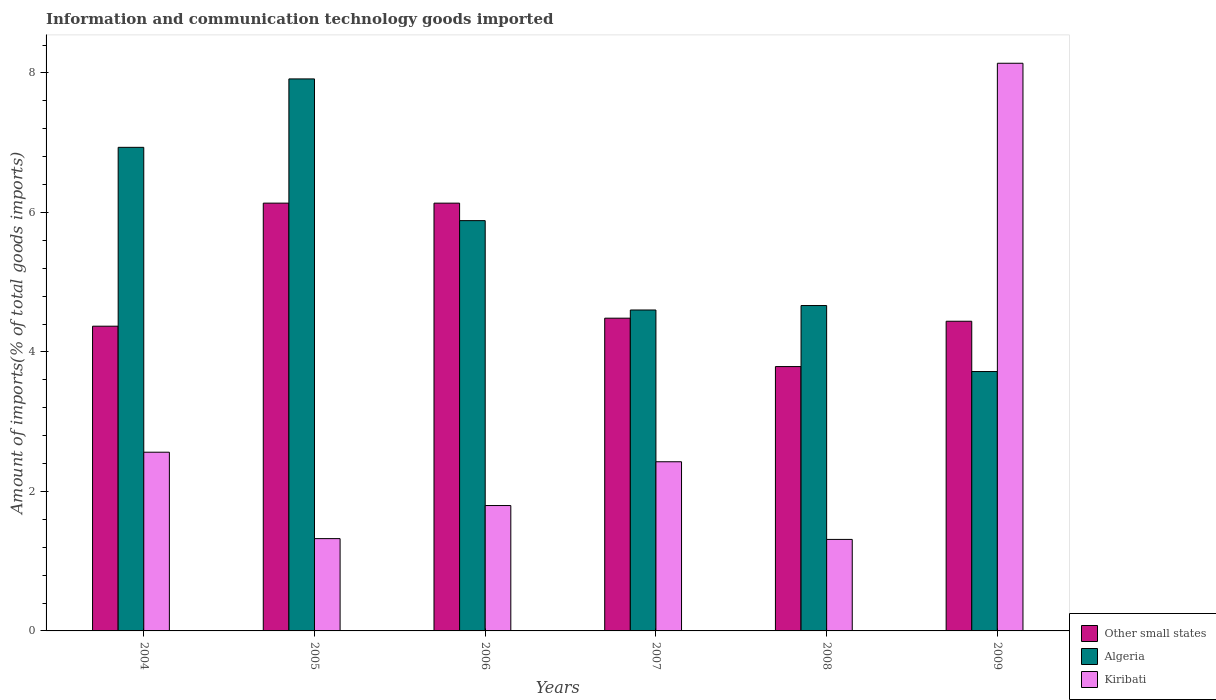How many different coloured bars are there?
Offer a very short reply. 3. How many groups of bars are there?
Offer a very short reply. 6. Are the number of bars on each tick of the X-axis equal?
Ensure brevity in your answer.  Yes. How many bars are there on the 3rd tick from the right?
Offer a very short reply. 3. What is the label of the 3rd group of bars from the left?
Give a very brief answer. 2006. What is the amount of goods imported in Kiribati in 2008?
Ensure brevity in your answer.  1.31. Across all years, what is the maximum amount of goods imported in Other small states?
Your answer should be very brief. 6.13. Across all years, what is the minimum amount of goods imported in Algeria?
Offer a terse response. 3.72. In which year was the amount of goods imported in Other small states minimum?
Provide a short and direct response. 2008. What is the total amount of goods imported in Kiribati in the graph?
Provide a succinct answer. 17.56. What is the difference between the amount of goods imported in Other small states in 2004 and that in 2007?
Your response must be concise. -0.11. What is the difference between the amount of goods imported in Algeria in 2005 and the amount of goods imported in Other small states in 2004?
Offer a terse response. 3.55. What is the average amount of goods imported in Kiribati per year?
Ensure brevity in your answer.  2.93. In the year 2005, what is the difference between the amount of goods imported in Algeria and amount of goods imported in Kiribati?
Offer a very short reply. 6.59. What is the ratio of the amount of goods imported in Kiribati in 2005 to that in 2007?
Make the answer very short. 0.55. Is the difference between the amount of goods imported in Algeria in 2005 and 2006 greater than the difference between the amount of goods imported in Kiribati in 2005 and 2006?
Your answer should be very brief. Yes. What is the difference between the highest and the second highest amount of goods imported in Kiribati?
Provide a short and direct response. 5.58. What is the difference between the highest and the lowest amount of goods imported in Kiribati?
Ensure brevity in your answer.  6.83. What does the 1st bar from the left in 2007 represents?
Ensure brevity in your answer.  Other small states. What does the 1st bar from the right in 2004 represents?
Offer a terse response. Kiribati. What is the difference between two consecutive major ticks on the Y-axis?
Give a very brief answer. 2. Are the values on the major ticks of Y-axis written in scientific E-notation?
Provide a succinct answer. No. How are the legend labels stacked?
Your response must be concise. Vertical. What is the title of the graph?
Provide a short and direct response. Information and communication technology goods imported. Does "Ecuador" appear as one of the legend labels in the graph?
Provide a succinct answer. No. What is the label or title of the Y-axis?
Your answer should be very brief. Amount of imports(% of total goods imports). What is the Amount of imports(% of total goods imports) in Other small states in 2004?
Provide a succinct answer. 4.37. What is the Amount of imports(% of total goods imports) of Algeria in 2004?
Provide a succinct answer. 6.93. What is the Amount of imports(% of total goods imports) of Kiribati in 2004?
Make the answer very short. 2.56. What is the Amount of imports(% of total goods imports) in Other small states in 2005?
Offer a terse response. 6.13. What is the Amount of imports(% of total goods imports) in Algeria in 2005?
Offer a terse response. 7.92. What is the Amount of imports(% of total goods imports) in Kiribati in 2005?
Your response must be concise. 1.32. What is the Amount of imports(% of total goods imports) in Other small states in 2006?
Ensure brevity in your answer.  6.13. What is the Amount of imports(% of total goods imports) of Algeria in 2006?
Provide a succinct answer. 5.88. What is the Amount of imports(% of total goods imports) in Kiribati in 2006?
Give a very brief answer. 1.8. What is the Amount of imports(% of total goods imports) of Other small states in 2007?
Keep it short and to the point. 4.48. What is the Amount of imports(% of total goods imports) of Algeria in 2007?
Your response must be concise. 4.6. What is the Amount of imports(% of total goods imports) in Kiribati in 2007?
Your answer should be compact. 2.43. What is the Amount of imports(% of total goods imports) of Other small states in 2008?
Your response must be concise. 3.79. What is the Amount of imports(% of total goods imports) of Algeria in 2008?
Make the answer very short. 4.67. What is the Amount of imports(% of total goods imports) in Kiribati in 2008?
Your answer should be very brief. 1.31. What is the Amount of imports(% of total goods imports) of Other small states in 2009?
Offer a terse response. 4.44. What is the Amount of imports(% of total goods imports) of Algeria in 2009?
Your answer should be compact. 3.72. What is the Amount of imports(% of total goods imports) in Kiribati in 2009?
Ensure brevity in your answer.  8.14. Across all years, what is the maximum Amount of imports(% of total goods imports) in Other small states?
Your answer should be compact. 6.13. Across all years, what is the maximum Amount of imports(% of total goods imports) of Algeria?
Offer a terse response. 7.92. Across all years, what is the maximum Amount of imports(% of total goods imports) in Kiribati?
Your answer should be compact. 8.14. Across all years, what is the minimum Amount of imports(% of total goods imports) of Other small states?
Offer a very short reply. 3.79. Across all years, what is the minimum Amount of imports(% of total goods imports) in Algeria?
Make the answer very short. 3.72. Across all years, what is the minimum Amount of imports(% of total goods imports) in Kiribati?
Your answer should be compact. 1.31. What is the total Amount of imports(% of total goods imports) in Other small states in the graph?
Your response must be concise. 29.35. What is the total Amount of imports(% of total goods imports) of Algeria in the graph?
Ensure brevity in your answer.  33.72. What is the total Amount of imports(% of total goods imports) in Kiribati in the graph?
Make the answer very short. 17.56. What is the difference between the Amount of imports(% of total goods imports) in Other small states in 2004 and that in 2005?
Keep it short and to the point. -1.76. What is the difference between the Amount of imports(% of total goods imports) of Algeria in 2004 and that in 2005?
Provide a short and direct response. -0.98. What is the difference between the Amount of imports(% of total goods imports) in Kiribati in 2004 and that in 2005?
Ensure brevity in your answer.  1.24. What is the difference between the Amount of imports(% of total goods imports) of Other small states in 2004 and that in 2006?
Provide a short and direct response. -1.76. What is the difference between the Amount of imports(% of total goods imports) of Algeria in 2004 and that in 2006?
Keep it short and to the point. 1.05. What is the difference between the Amount of imports(% of total goods imports) in Kiribati in 2004 and that in 2006?
Give a very brief answer. 0.76. What is the difference between the Amount of imports(% of total goods imports) in Other small states in 2004 and that in 2007?
Ensure brevity in your answer.  -0.12. What is the difference between the Amount of imports(% of total goods imports) in Algeria in 2004 and that in 2007?
Your answer should be compact. 2.33. What is the difference between the Amount of imports(% of total goods imports) in Kiribati in 2004 and that in 2007?
Make the answer very short. 0.14. What is the difference between the Amount of imports(% of total goods imports) in Other small states in 2004 and that in 2008?
Your answer should be very brief. 0.58. What is the difference between the Amount of imports(% of total goods imports) of Algeria in 2004 and that in 2008?
Ensure brevity in your answer.  2.27. What is the difference between the Amount of imports(% of total goods imports) in Kiribati in 2004 and that in 2008?
Ensure brevity in your answer.  1.25. What is the difference between the Amount of imports(% of total goods imports) in Other small states in 2004 and that in 2009?
Make the answer very short. -0.07. What is the difference between the Amount of imports(% of total goods imports) of Algeria in 2004 and that in 2009?
Your response must be concise. 3.21. What is the difference between the Amount of imports(% of total goods imports) in Kiribati in 2004 and that in 2009?
Provide a succinct answer. -5.58. What is the difference between the Amount of imports(% of total goods imports) in Algeria in 2005 and that in 2006?
Provide a short and direct response. 2.03. What is the difference between the Amount of imports(% of total goods imports) in Kiribati in 2005 and that in 2006?
Your response must be concise. -0.47. What is the difference between the Amount of imports(% of total goods imports) in Other small states in 2005 and that in 2007?
Keep it short and to the point. 1.65. What is the difference between the Amount of imports(% of total goods imports) in Algeria in 2005 and that in 2007?
Ensure brevity in your answer.  3.31. What is the difference between the Amount of imports(% of total goods imports) in Kiribati in 2005 and that in 2007?
Your answer should be compact. -1.1. What is the difference between the Amount of imports(% of total goods imports) in Other small states in 2005 and that in 2008?
Ensure brevity in your answer.  2.34. What is the difference between the Amount of imports(% of total goods imports) of Algeria in 2005 and that in 2008?
Give a very brief answer. 3.25. What is the difference between the Amount of imports(% of total goods imports) of Kiribati in 2005 and that in 2008?
Provide a short and direct response. 0.01. What is the difference between the Amount of imports(% of total goods imports) of Other small states in 2005 and that in 2009?
Offer a terse response. 1.69. What is the difference between the Amount of imports(% of total goods imports) of Algeria in 2005 and that in 2009?
Keep it short and to the point. 4.2. What is the difference between the Amount of imports(% of total goods imports) of Kiribati in 2005 and that in 2009?
Your answer should be compact. -6.82. What is the difference between the Amount of imports(% of total goods imports) in Other small states in 2006 and that in 2007?
Provide a short and direct response. 1.65. What is the difference between the Amount of imports(% of total goods imports) in Algeria in 2006 and that in 2007?
Your answer should be very brief. 1.28. What is the difference between the Amount of imports(% of total goods imports) in Kiribati in 2006 and that in 2007?
Offer a very short reply. -0.63. What is the difference between the Amount of imports(% of total goods imports) of Other small states in 2006 and that in 2008?
Ensure brevity in your answer.  2.34. What is the difference between the Amount of imports(% of total goods imports) in Algeria in 2006 and that in 2008?
Keep it short and to the point. 1.22. What is the difference between the Amount of imports(% of total goods imports) in Kiribati in 2006 and that in 2008?
Your response must be concise. 0.49. What is the difference between the Amount of imports(% of total goods imports) of Other small states in 2006 and that in 2009?
Provide a short and direct response. 1.69. What is the difference between the Amount of imports(% of total goods imports) of Algeria in 2006 and that in 2009?
Offer a very short reply. 2.16. What is the difference between the Amount of imports(% of total goods imports) in Kiribati in 2006 and that in 2009?
Your answer should be very brief. -6.34. What is the difference between the Amount of imports(% of total goods imports) in Other small states in 2007 and that in 2008?
Make the answer very short. 0.69. What is the difference between the Amount of imports(% of total goods imports) of Algeria in 2007 and that in 2008?
Your answer should be very brief. -0.06. What is the difference between the Amount of imports(% of total goods imports) of Kiribati in 2007 and that in 2008?
Your response must be concise. 1.11. What is the difference between the Amount of imports(% of total goods imports) of Other small states in 2007 and that in 2009?
Keep it short and to the point. 0.04. What is the difference between the Amount of imports(% of total goods imports) in Algeria in 2007 and that in 2009?
Keep it short and to the point. 0.88. What is the difference between the Amount of imports(% of total goods imports) in Kiribati in 2007 and that in 2009?
Provide a succinct answer. -5.71. What is the difference between the Amount of imports(% of total goods imports) of Other small states in 2008 and that in 2009?
Your answer should be very brief. -0.65. What is the difference between the Amount of imports(% of total goods imports) in Algeria in 2008 and that in 2009?
Offer a very short reply. 0.95. What is the difference between the Amount of imports(% of total goods imports) of Kiribati in 2008 and that in 2009?
Give a very brief answer. -6.83. What is the difference between the Amount of imports(% of total goods imports) in Other small states in 2004 and the Amount of imports(% of total goods imports) in Algeria in 2005?
Provide a succinct answer. -3.55. What is the difference between the Amount of imports(% of total goods imports) in Other small states in 2004 and the Amount of imports(% of total goods imports) in Kiribati in 2005?
Your answer should be very brief. 3.05. What is the difference between the Amount of imports(% of total goods imports) of Algeria in 2004 and the Amount of imports(% of total goods imports) of Kiribati in 2005?
Make the answer very short. 5.61. What is the difference between the Amount of imports(% of total goods imports) in Other small states in 2004 and the Amount of imports(% of total goods imports) in Algeria in 2006?
Make the answer very short. -1.51. What is the difference between the Amount of imports(% of total goods imports) in Other small states in 2004 and the Amount of imports(% of total goods imports) in Kiribati in 2006?
Make the answer very short. 2.57. What is the difference between the Amount of imports(% of total goods imports) of Algeria in 2004 and the Amount of imports(% of total goods imports) of Kiribati in 2006?
Offer a very short reply. 5.14. What is the difference between the Amount of imports(% of total goods imports) of Other small states in 2004 and the Amount of imports(% of total goods imports) of Algeria in 2007?
Offer a very short reply. -0.23. What is the difference between the Amount of imports(% of total goods imports) of Other small states in 2004 and the Amount of imports(% of total goods imports) of Kiribati in 2007?
Offer a terse response. 1.94. What is the difference between the Amount of imports(% of total goods imports) in Algeria in 2004 and the Amount of imports(% of total goods imports) in Kiribati in 2007?
Make the answer very short. 4.51. What is the difference between the Amount of imports(% of total goods imports) in Other small states in 2004 and the Amount of imports(% of total goods imports) in Algeria in 2008?
Ensure brevity in your answer.  -0.3. What is the difference between the Amount of imports(% of total goods imports) of Other small states in 2004 and the Amount of imports(% of total goods imports) of Kiribati in 2008?
Your response must be concise. 3.06. What is the difference between the Amount of imports(% of total goods imports) of Algeria in 2004 and the Amount of imports(% of total goods imports) of Kiribati in 2008?
Ensure brevity in your answer.  5.62. What is the difference between the Amount of imports(% of total goods imports) of Other small states in 2004 and the Amount of imports(% of total goods imports) of Algeria in 2009?
Your response must be concise. 0.65. What is the difference between the Amount of imports(% of total goods imports) of Other small states in 2004 and the Amount of imports(% of total goods imports) of Kiribati in 2009?
Your response must be concise. -3.77. What is the difference between the Amount of imports(% of total goods imports) of Algeria in 2004 and the Amount of imports(% of total goods imports) of Kiribati in 2009?
Ensure brevity in your answer.  -1.21. What is the difference between the Amount of imports(% of total goods imports) in Other small states in 2005 and the Amount of imports(% of total goods imports) in Algeria in 2006?
Ensure brevity in your answer.  0.25. What is the difference between the Amount of imports(% of total goods imports) in Other small states in 2005 and the Amount of imports(% of total goods imports) in Kiribati in 2006?
Provide a short and direct response. 4.34. What is the difference between the Amount of imports(% of total goods imports) in Algeria in 2005 and the Amount of imports(% of total goods imports) in Kiribati in 2006?
Provide a short and direct response. 6.12. What is the difference between the Amount of imports(% of total goods imports) in Other small states in 2005 and the Amount of imports(% of total goods imports) in Algeria in 2007?
Your answer should be compact. 1.53. What is the difference between the Amount of imports(% of total goods imports) in Other small states in 2005 and the Amount of imports(% of total goods imports) in Kiribati in 2007?
Provide a succinct answer. 3.71. What is the difference between the Amount of imports(% of total goods imports) of Algeria in 2005 and the Amount of imports(% of total goods imports) of Kiribati in 2007?
Provide a short and direct response. 5.49. What is the difference between the Amount of imports(% of total goods imports) in Other small states in 2005 and the Amount of imports(% of total goods imports) in Algeria in 2008?
Your response must be concise. 1.47. What is the difference between the Amount of imports(% of total goods imports) of Other small states in 2005 and the Amount of imports(% of total goods imports) of Kiribati in 2008?
Provide a succinct answer. 4.82. What is the difference between the Amount of imports(% of total goods imports) of Algeria in 2005 and the Amount of imports(% of total goods imports) of Kiribati in 2008?
Keep it short and to the point. 6.6. What is the difference between the Amount of imports(% of total goods imports) in Other small states in 2005 and the Amount of imports(% of total goods imports) in Algeria in 2009?
Provide a succinct answer. 2.41. What is the difference between the Amount of imports(% of total goods imports) in Other small states in 2005 and the Amount of imports(% of total goods imports) in Kiribati in 2009?
Your answer should be compact. -2.01. What is the difference between the Amount of imports(% of total goods imports) of Algeria in 2005 and the Amount of imports(% of total goods imports) of Kiribati in 2009?
Ensure brevity in your answer.  -0.22. What is the difference between the Amount of imports(% of total goods imports) of Other small states in 2006 and the Amount of imports(% of total goods imports) of Algeria in 2007?
Make the answer very short. 1.53. What is the difference between the Amount of imports(% of total goods imports) in Other small states in 2006 and the Amount of imports(% of total goods imports) in Kiribati in 2007?
Keep it short and to the point. 3.71. What is the difference between the Amount of imports(% of total goods imports) in Algeria in 2006 and the Amount of imports(% of total goods imports) in Kiribati in 2007?
Offer a very short reply. 3.46. What is the difference between the Amount of imports(% of total goods imports) in Other small states in 2006 and the Amount of imports(% of total goods imports) in Algeria in 2008?
Your response must be concise. 1.47. What is the difference between the Amount of imports(% of total goods imports) of Other small states in 2006 and the Amount of imports(% of total goods imports) of Kiribati in 2008?
Offer a terse response. 4.82. What is the difference between the Amount of imports(% of total goods imports) in Algeria in 2006 and the Amount of imports(% of total goods imports) in Kiribati in 2008?
Your answer should be compact. 4.57. What is the difference between the Amount of imports(% of total goods imports) of Other small states in 2006 and the Amount of imports(% of total goods imports) of Algeria in 2009?
Provide a short and direct response. 2.41. What is the difference between the Amount of imports(% of total goods imports) of Other small states in 2006 and the Amount of imports(% of total goods imports) of Kiribati in 2009?
Offer a very short reply. -2.01. What is the difference between the Amount of imports(% of total goods imports) in Algeria in 2006 and the Amount of imports(% of total goods imports) in Kiribati in 2009?
Ensure brevity in your answer.  -2.26. What is the difference between the Amount of imports(% of total goods imports) in Other small states in 2007 and the Amount of imports(% of total goods imports) in Algeria in 2008?
Keep it short and to the point. -0.18. What is the difference between the Amount of imports(% of total goods imports) of Other small states in 2007 and the Amount of imports(% of total goods imports) of Kiribati in 2008?
Ensure brevity in your answer.  3.17. What is the difference between the Amount of imports(% of total goods imports) in Algeria in 2007 and the Amount of imports(% of total goods imports) in Kiribati in 2008?
Give a very brief answer. 3.29. What is the difference between the Amount of imports(% of total goods imports) of Other small states in 2007 and the Amount of imports(% of total goods imports) of Algeria in 2009?
Ensure brevity in your answer.  0.77. What is the difference between the Amount of imports(% of total goods imports) in Other small states in 2007 and the Amount of imports(% of total goods imports) in Kiribati in 2009?
Make the answer very short. -3.66. What is the difference between the Amount of imports(% of total goods imports) of Algeria in 2007 and the Amount of imports(% of total goods imports) of Kiribati in 2009?
Your response must be concise. -3.54. What is the difference between the Amount of imports(% of total goods imports) of Other small states in 2008 and the Amount of imports(% of total goods imports) of Algeria in 2009?
Offer a terse response. 0.07. What is the difference between the Amount of imports(% of total goods imports) of Other small states in 2008 and the Amount of imports(% of total goods imports) of Kiribati in 2009?
Make the answer very short. -4.35. What is the difference between the Amount of imports(% of total goods imports) of Algeria in 2008 and the Amount of imports(% of total goods imports) of Kiribati in 2009?
Your response must be concise. -3.47. What is the average Amount of imports(% of total goods imports) in Other small states per year?
Your answer should be compact. 4.89. What is the average Amount of imports(% of total goods imports) in Algeria per year?
Provide a short and direct response. 5.62. What is the average Amount of imports(% of total goods imports) of Kiribati per year?
Offer a terse response. 2.93. In the year 2004, what is the difference between the Amount of imports(% of total goods imports) in Other small states and Amount of imports(% of total goods imports) in Algeria?
Keep it short and to the point. -2.56. In the year 2004, what is the difference between the Amount of imports(% of total goods imports) in Other small states and Amount of imports(% of total goods imports) in Kiribati?
Give a very brief answer. 1.81. In the year 2004, what is the difference between the Amount of imports(% of total goods imports) of Algeria and Amount of imports(% of total goods imports) of Kiribati?
Make the answer very short. 4.37. In the year 2005, what is the difference between the Amount of imports(% of total goods imports) of Other small states and Amount of imports(% of total goods imports) of Algeria?
Provide a short and direct response. -1.78. In the year 2005, what is the difference between the Amount of imports(% of total goods imports) in Other small states and Amount of imports(% of total goods imports) in Kiribati?
Offer a terse response. 4.81. In the year 2005, what is the difference between the Amount of imports(% of total goods imports) of Algeria and Amount of imports(% of total goods imports) of Kiribati?
Give a very brief answer. 6.59. In the year 2006, what is the difference between the Amount of imports(% of total goods imports) in Other small states and Amount of imports(% of total goods imports) in Algeria?
Provide a short and direct response. 0.25. In the year 2006, what is the difference between the Amount of imports(% of total goods imports) of Other small states and Amount of imports(% of total goods imports) of Kiribati?
Offer a very short reply. 4.34. In the year 2006, what is the difference between the Amount of imports(% of total goods imports) of Algeria and Amount of imports(% of total goods imports) of Kiribati?
Provide a short and direct response. 4.09. In the year 2007, what is the difference between the Amount of imports(% of total goods imports) in Other small states and Amount of imports(% of total goods imports) in Algeria?
Offer a very short reply. -0.12. In the year 2007, what is the difference between the Amount of imports(% of total goods imports) of Other small states and Amount of imports(% of total goods imports) of Kiribati?
Keep it short and to the point. 2.06. In the year 2007, what is the difference between the Amount of imports(% of total goods imports) in Algeria and Amount of imports(% of total goods imports) in Kiribati?
Provide a succinct answer. 2.18. In the year 2008, what is the difference between the Amount of imports(% of total goods imports) in Other small states and Amount of imports(% of total goods imports) in Algeria?
Your response must be concise. -0.88. In the year 2008, what is the difference between the Amount of imports(% of total goods imports) of Other small states and Amount of imports(% of total goods imports) of Kiribati?
Offer a terse response. 2.48. In the year 2008, what is the difference between the Amount of imports(% of total goods imports) of Algeria and Amount of imports(% of total goods imports) of Kiribati?
Ensure brevity in your answer.  3.35. In the year 2009, what is the difference between the Amount of imports(% of total goods imports) of Other small states and Amount of imports(% of total goods imports) of Algeria?
Make the answer very short. 0.72. In the year 2009, what is the difference between the Amount of imports(% of total goods imports) in Other small states and Amount of imports(% of total goods imports) in Kiribati?
Your response must be concise. -3.7. In the year 2009, what is the difference between the Amount of imports(% of total goods imports) in Algeria and Amount of imports(% of total goods imports) in Kiribati?
Give a very brief answer. -4.42. What is the ratio of the Amount of imports(% of total goods imports) of Other small states in 2004 to that in 2005?
Your answer should be compact. 0.71. What is the ratio of the Amount of imports(% of total goods imports) of Algeria in 2004 to that in 2005?
Ensure brevity in your answer.  0.88. What is the ratio of the Amount of imports(% of total goods imports) in Kiribati in 2004 to that in 2005?
Your answer should be compact. 1.94. What is the ratio of the Amount of imports(% of total goods imports) in Other small states in 2004 to that in 2006?
Provide a succinct answer. 0.71. What is the ratio of the Amount of imports(% of total goods imports) in Algeria in 2004 to that in 2006?
Offer a terse response. 1.18. What is the ratio of the Amount of imports(% of total goods imports) in Kiribati in 2004 to that in 2006?
Ensure brevity in your answer.  1.43. What is the ratio of the Amount of imports(% of total goods imports) of Other small states in 2004 to that in 2007?
Your answer should be very brief. 0.97. What is the ratio of the Amount of imports(% of total goods imports) in Algeria in 2004 to that in 2007?
Provide a succinct answer. 1.51. What is the ratio of the Amount of imports(% of total goods imports) of Kiribati in 2004 to that in 2007?
Your response must be concise. 1.06. What is the ratio of the Amount of imports(% of total goods imports) in Other small states in 2004 to that in 2008?
Give a very brief answer. 1.15. What is the ratio of the Amount of imports(% of total goods imports) in Algeria in 2004 to that in 2008?
Your response must be concise. 1.49. What is the ratio of the Amount of imports(% of total goods imports) in Kiribati in 2004 to that in 2008?
Keep it short and to the point. 1.95. What is the ratio of the Amount of imports(% of total goods imports) in Algeria in 2004 to that in 2009?
Your answer should be compact. 1.86. What is the ratio of the Amount of imports(% of total goods imports) in Kiribati in 2004 to that in 2009?
Make the answer very short. 0.31. What is the ratio of the Amount of imports(% of total goods imports) in Algeria in 2005 to that in 2006?
Ensure brevity in your answer.  1.35. What is the ratio of the Amount of imports(% of total goods imports) of Kiribati in 2005 to that in 2006?
Give a very brief answer. 0.74. What is the ratio of the Amount of imports(% of total goods imports) of Other small states in 2005 to that in 2007?
Give a very brief answer. 1.37. What is the ratio of the Amount of imports(% of total goods imports) in Algeria in 2005 to that in 2007?
Ensure brevity in your answer.  1.72. What is the ratio of the Amount of imports(% of total goods imports) in Kiribati in 2005 to that in 2007?
Your answer should be compact. 0.55. What is the ratio of the Amount of imports(% of total goods imports) of Other small states in 2005 to that in 2008?
Make the answer very short. 1.62. What is the ratio of the Amount of imports(% of total goods imports) in Algeria in 2005 to that in 2008?
Your answer should be very brief. 1.7. What is the ratio of the Amount of imports(% of total goods imports) of Kiribati in 2005 to that in 2008?
Provide a short and direct response. 1.01. What is the ratio of the Amount of imports(% of total goods imports) of Other small states in 2005 to that in 2009?
Your answer should be very brief. 1.38. What is the ratio of the Amount of imports(% of total goods imports) of Algeria in 2005 to that in 2009?
Provide a succinct answer. 2.13. What is the ratio of the Amount of imports(% of total goods imports) of Kiribati in 2005 to that in 2009?
Provide a succinct answer. 0.16. What is the ratio of the Amount of imports(% of total goods imports) in Other small states in 2006 to that in 2007?
Your answer should be very brief. 1.37. What is the ratio of the Amount of imports(% of total goods imports) in Algeria in 2006 to that in 2007?
Make the answer very short. 1.28. What is the ratio of the Amount of imports(% of total goods imports) in Kiribati in 2006 to that in 2007?
Provide a short and direct response. 0.74. What is the ratio of the Amount of imports(% of total goods imports) in Other small states in 2006 to that in 2008?
Offer a very short reply. 1.62. What is the ratio of the Amount of imports(% of total goods imports) in Algeria in 2006 to that in 2008?
Offer a very short reply. 1.26. What is the ratio of the Amount of imports(% of total goods imports) of Kiribati in 2006 to that in 2008?
Give a very brief answer. 1.37. What is the ratio of the Amount of imports(% of total goods imports) of Other small states in 2006 to that in 2009?
Your answer should be compact. 1.38. What is the ratio of the Amount of imports(% of total goods imports) of Algeria in 2006 to that in 2009?
Make the answer very short. 1.58. What is the ratio of the Amount of imports(% of total goods imports) of Kiribati in 2006 to that in 2009?
Make the answer very short. 0.22. What is the ratio of the Amount of imports(% of total goods imports) in Other small states in 2007 to that in 2008?
Give a very brief answer. 1.18. What is the ratio of the Amount of imports(% of total goods imports) of Algeria in 2007 to that in 2008?
Your response must be concise. 0.99. What is the ratio of the Amount of imports(% of total goods imports) in Kiribati in 2007 to that in 2008?
Keep it short and to the point. 1.85. What is the ratio of the Amount of imports(% of total goods imports) in Other small states in 2007 to that in 2009?
Your response must be concise. 1.01. What is the ratio of the Amount of imports(% of total goods imports) in Algeria in 2007 to that in 2009?
Keep it short and to the point. 1.24. What is the ratio of the Amount of imports(% of total goods imports) in Kiribati in 2007 to that in 2009?
Your answer should be very brief. 0.3. What is the ratio of the Amount of imports(% of total goods imports) in Other small states in 2008 to that in 2009?
Give a very brief answer. 0.85. What is the ratio of the Amount of imports(% of total goods imports) in Algeria in 2008 to that in 2009?
Offer a terse response. 1.25. What is the ratio of the Amount of imports(% of total goods imports) in Kiribati in 2008 to that in 2009?
Provide a short and direct response. 0.16. What is the difference between the highest and the second highest Amount of imports(% of total goods imports) in Other small states?
Offer a very short reply. 0. What is the difference between the highest and the second highest Amount of imports(% of total goods imports) in Algeria?
Offer a very short reply. 0.98. What is the difference between the highest and the second highest Amount of imports(% of total goods imports) in Kiribati?
Your answer should be compact. 5.58. What is the difference between the highest and the lowest Amount of imports(% of total goods imports) in Other small states?
Offer a terse response. 2.34. What is the difference between the highest and the lowest Amount of imports(% of total goods imports) of Algeria?
Your answer should be compact. 4.2. What is the difference between the highest and the lowest Amount of imports(% of total goods imports) of Kiribati?
Make the answer very short. 6.83. 